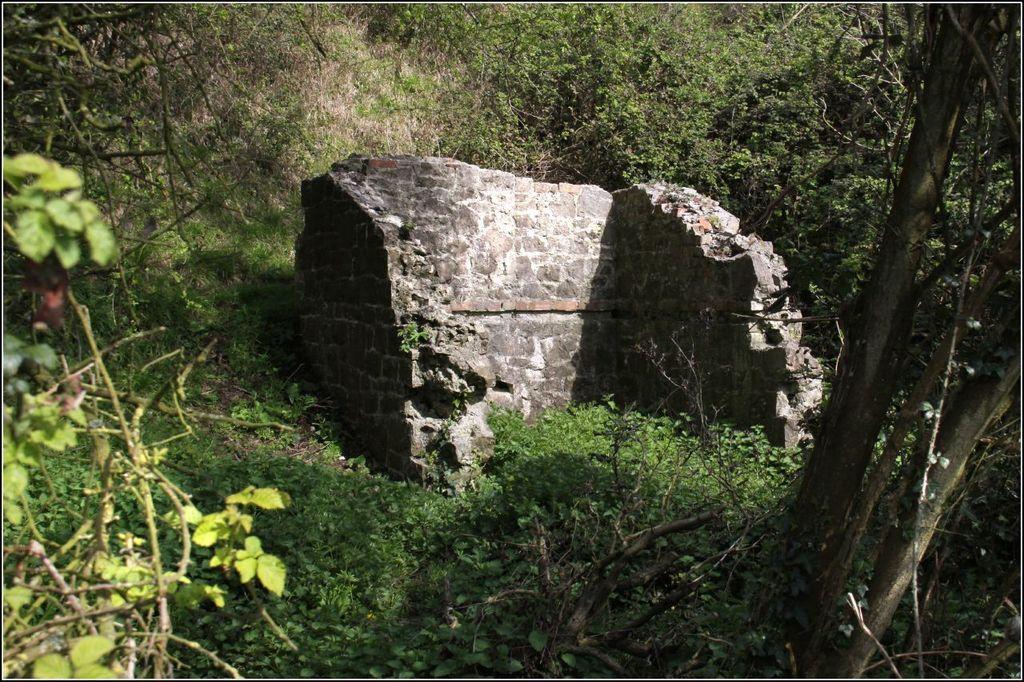Can you describe this image briefly? In this picture I can see the wall in the center and around it I can see the plants and trees. 